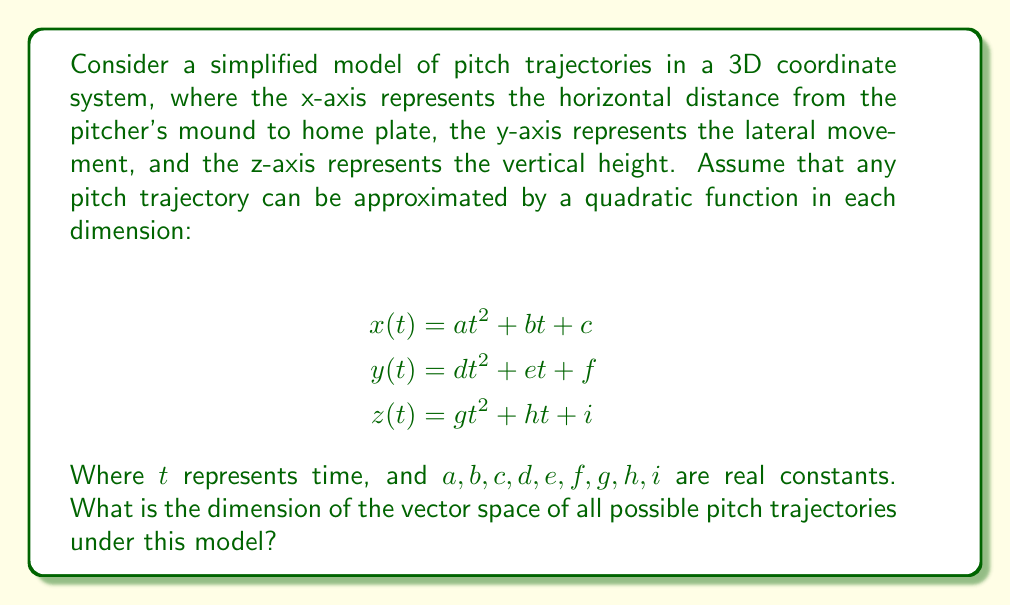What is the answer to this math problem? To determine the dimension of the vector space of all possible pitch trajectories, we need to consider the number of independent parameters that define a unique trajectory:

1. For $x(t)$:
   - $a$ determines the acceleration in the x-direction
   - $b$ determines the initial velocity in the x-direction
   - $c$ determines the initial position in the x-direction

2. For $y(t)$:
   - $d$ determines the lateral acceleration
   - $e$ determines the initial lateral velocity
   - $f$ determines the initial lateral position

3. For $z(t)$:
   - $g$ determines the vertical acceleration
   - $h$ determines the initial vertical velocity
   - $i$ determines the initial vertical position

Each of these parameters $(a, b, c, d, e, f, g, h, i)$ can be chosen independently and contributes to defining a unique trajectory. Therefore, each parameter corresponds to a basis vector in the vector space of pitch trajectories.

The number of independent parameters is 9, which means the vector space has 9 dimensions. Each unique combination of these 9 parameters represents a distinct pitch trajectory in our simplified model.

This 9-dimensional vector space allows for a wide variety of pitches, including fastballs, curveballs, sliders, and changeups, each with its unique combination of initial position, velocity, and acceleration in all three dimensions.
Answer: 9 